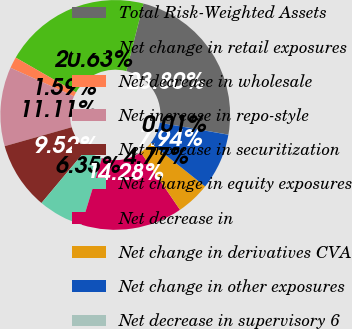<chart> <loc_0><loc_0><loc_500><loc_500><pie_chart><fcel>Total Risk-Weighted Assets<fcel>Net change in retail exposures<fcel>Net decrease in wholesale<fcel>Net increase in repo-style<fcel>Net increase in securitization<fcel>Net change in equity exposures<fcel>Net decrease in<fcel>Net change in derivatives CVA<fcel>Net change in other exposures<fcel>Net decrease in supervisory 6<nl><fcel>23.8%<fcel>20.63%<fcel>1.59%<fcel>11.11%<fcel>9.52%<fcel>6.35%<fcel>14.28%<fcel>4.77%<fcel>7.94%<fcel>0.01%<nl></chart> 